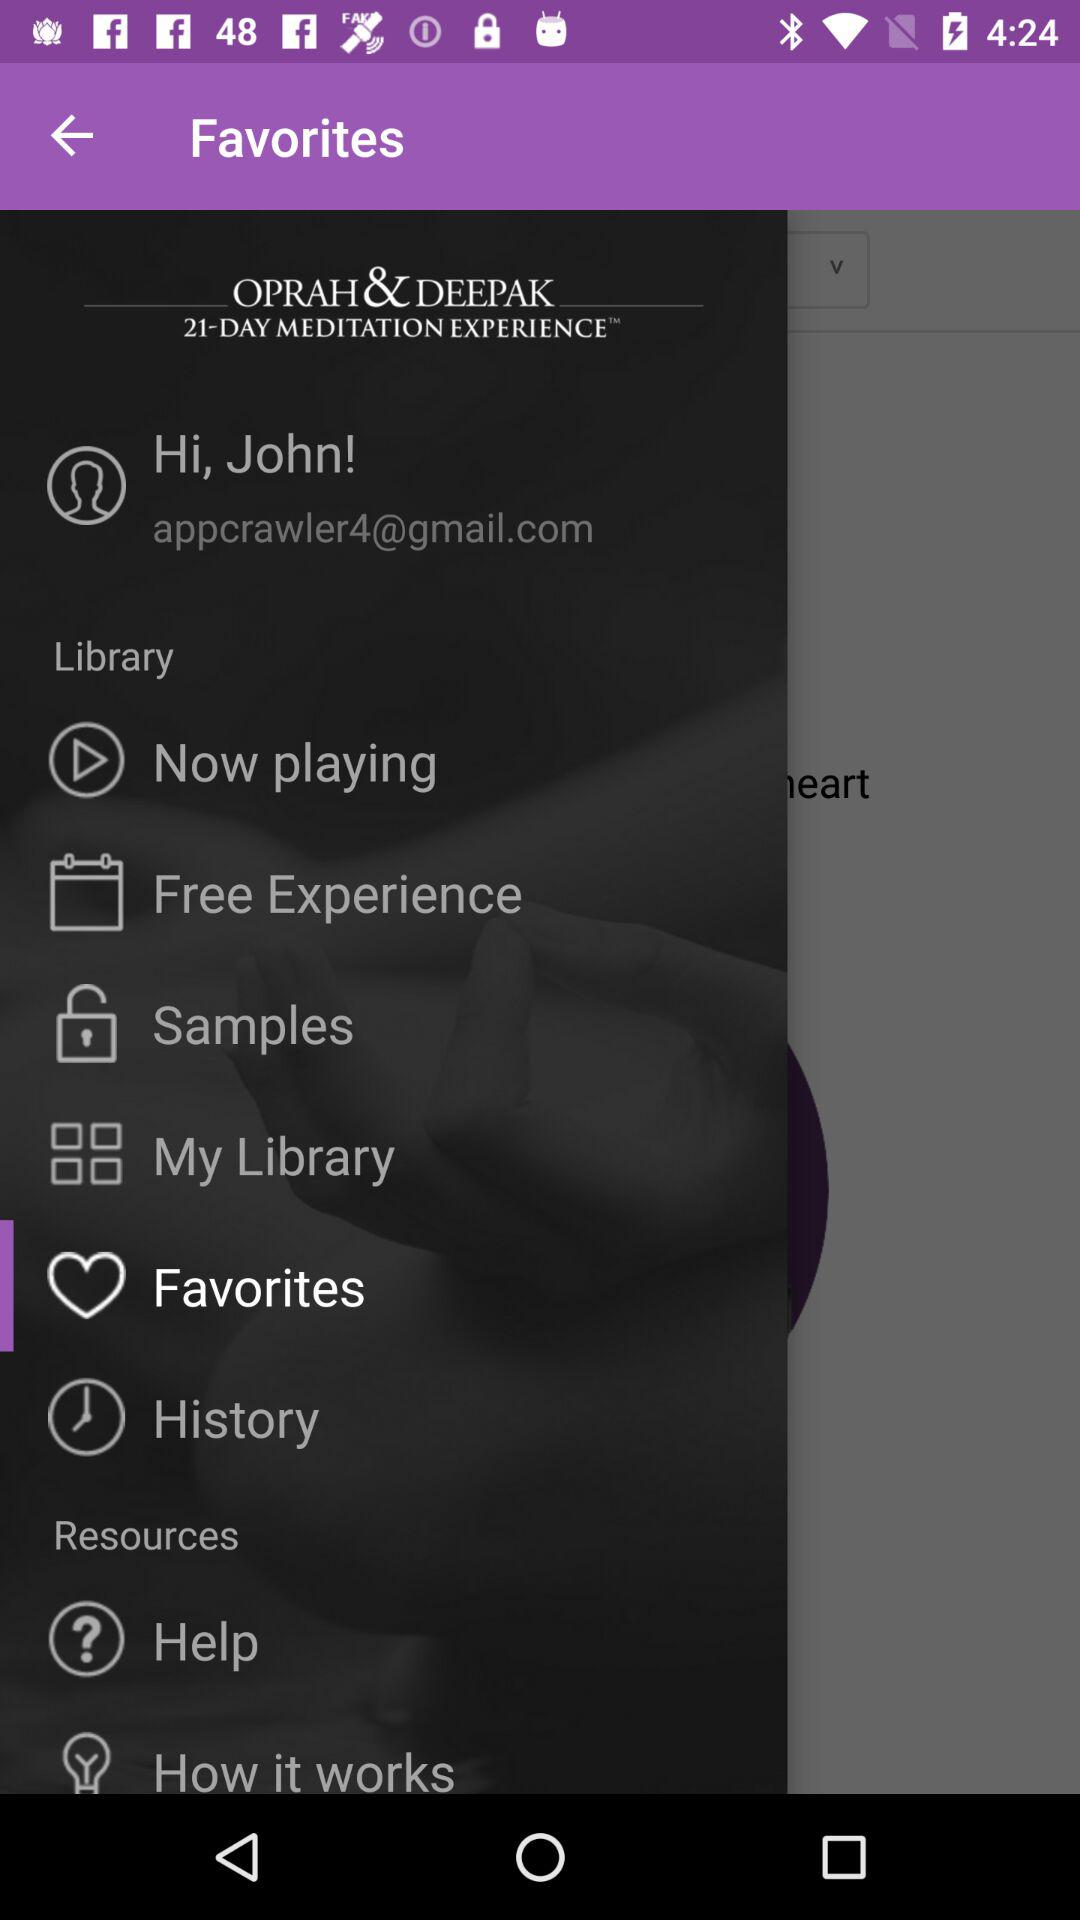What is the name of the user? The name of the user is John. 